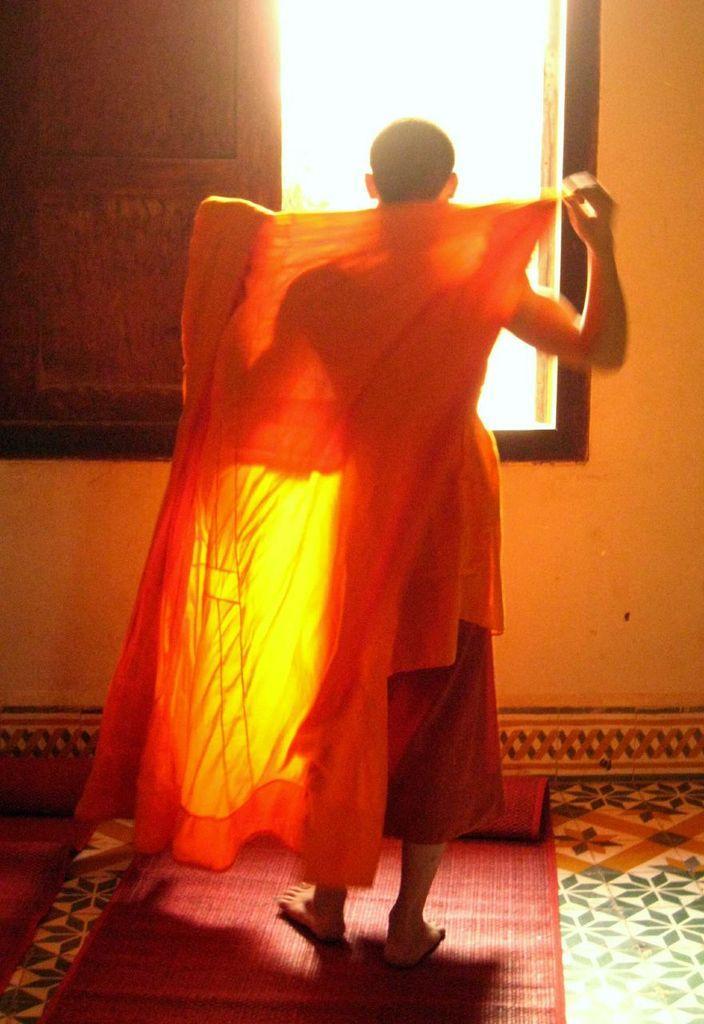Please provide a concise description of this image. In the image I can see a person is holding a cloth. He is on the mat. In front I can see window and wall. 